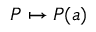<formula> <loc_0><loc_0><loc_500><loc_500>P \mapsto P ( a )</formula> 